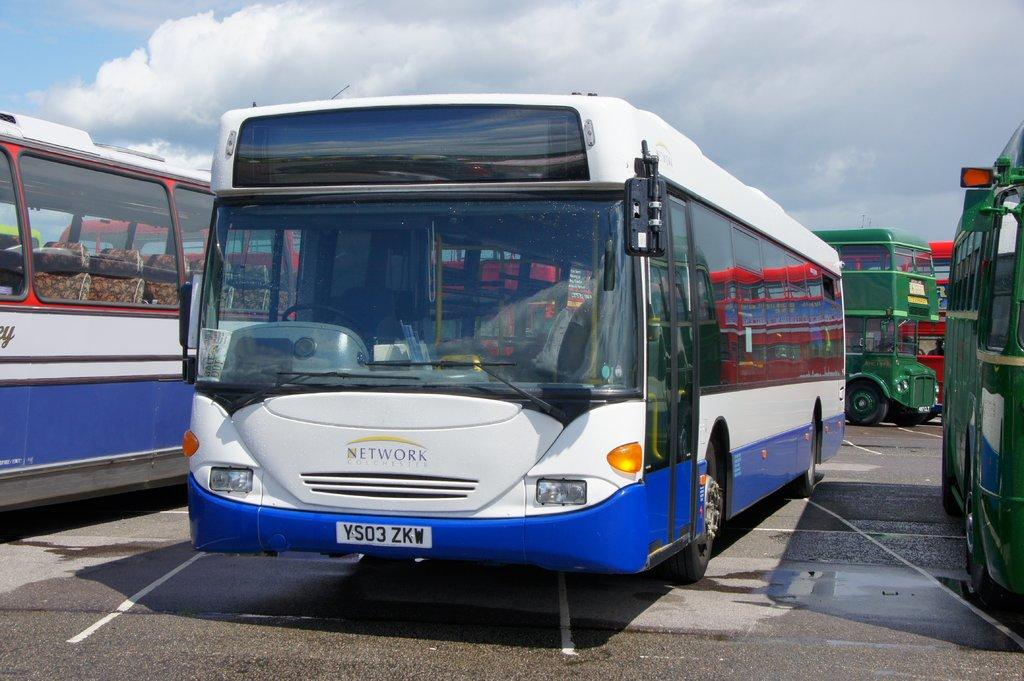How many buses can be seen in the image? There are two buses in the image. What colors are the two buses? The two buses are white and blue in color. Are there any other buses in the image? Yes, there are other buses in the image. What colors are the other buses? The other buses are green and red in color. Where are the buses located in the image? The buses are on the ground. What can be seen in the background of the image? The sky is visible in the background of the image. Can you tell me how many pears are on the store shelf in the image? There is no store or shelf with pears present in the image. What is the mass of the buses in the image? The mass of the buses cannot be determined from the image alone, as it does not provide information about their weight or size. 